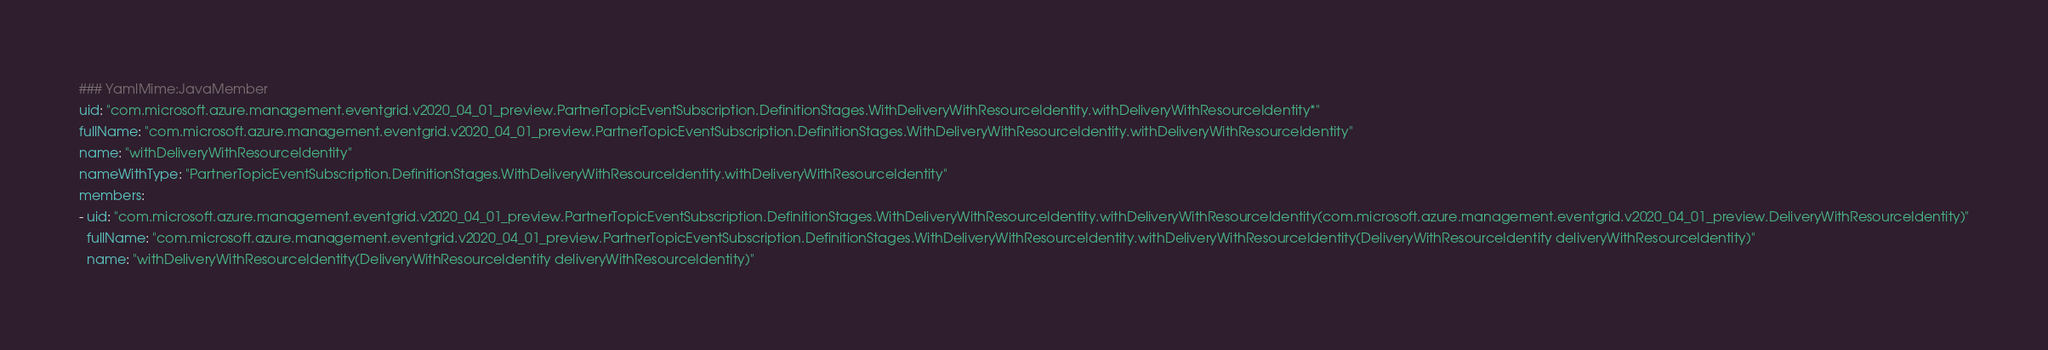Convert code to text. <code><loc_0><loc_0><loc_500><loc_500><_YAML_>### YamlMime:JavaMember
uid: "com.microsoft.azure.management.eventgrid.v2020_04_01_preview.PartnerTopicEventSubscription.DefinitionStages.WithDeliveryWithResourceIdentity.withDeliveryWithResourceIdentity*"
fullName: "com.microsoft.azure.management.eventgrid.v2020_04_01_preview.PartnerTopicEventSubscription.DefinitionStages.WithDeliveryWithResourceIdentity.withDeliveryWithResourceIdentity"
name: "withDeliveryWithResourceIdentity"
nameWithType: "PartnerTopicEventSubscription.DefinitionStages.WithDeliveryWithResourceIdentity.withDeliveryWithResourceIdentity"
members:
- uid: "com.microsoft.azure.management.eventgrid.v2020_04_01_preview.PartnerTopicEventSubscription.DefinitionStages.WithDeliveryWithResourceIdentity.withDeliveryWithResourceIdentity(com.microsoft.azure.management.eventgrid.v2020_04_01_preview.DeliveryWithResourceIdentity)"
  fullName: "com.microsoft.azure.management.eventgrid.v2020_04_01_preview.PartnerTopicEventSubscription.DefinitionStages.WithDeliveryWithResourceIdentity.withDeliveryWithResourceIdentity(DeliveryWithResourceIdentity deliveryWithResourceIdentity)"
  name: "withDeliveryWithResourceIdentity(DeliveryWithResourceIdentity deliveryWithResourceIdentity)"</code> 